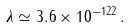Convert formula to latex. <formula><loc_0><loc_0><loc_500><loc_500>\lambda \simeq 3 . 6 \times 1 0 ^ { - 1 2 2 } \, .</formula> 